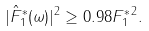<formula> <loc_0><loc_0><loc_500><loc_500>| \hat { F } _ { 1 } ^ { * } ( \omega ) | ^ { 2 } \geq 0 . 9 8 \| F _ { 1 } ^ { * } \| ^ { 2 } .</formula> 